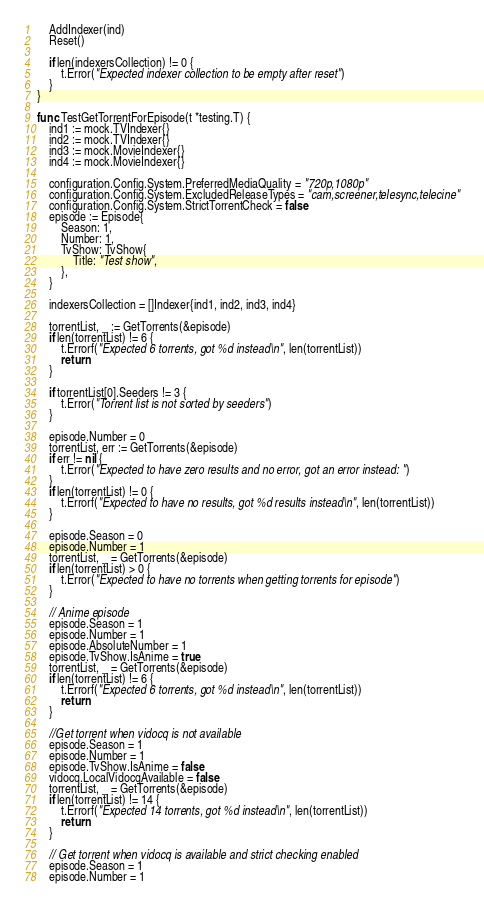<code> <loc_0><loc_0><loc_500><loc_500><_Go_>	AddIndexer(ind)
	Reset()

	if len(indexersCollection) != 0 {
		t.Error("Expected indexer collection to be empty after reset")
	}
}

func TestGetTorrentForEpisode(t *testing.T) {
	ind1 := mock.TVIndexer{}
	ind2 := mock.TVIndexer{}
	ind3 := mock.MovieIndexer{}
	ind4 := mock.MovieIndexer{}

	configuration.Config.System.PreferredMediaQuality = "720p,1080p"
	configuration.Config.System.ExcludedReleaseTypes = "cam,screener,telesync,telecine"
	configuration.Config.System.StrictTorrentCheck = false
	episode := Episode{
		Season: 1,
		Number: 1,
		TvShow: TvShow{
			Title: "Test show",
		},
	}

	indexersCollection = []Indexer{ind1, ind2, ind3, ind4}

	torrentList, _ := GetTorrents(&episode)
	if len(torrentList) != 6 {
		t.Errorf("Expected 6 torrents, got %d instead\n", len(torrentList))
		return
	}

	if torrentList[0].Seeders != 3 {
		t.Error("Torrent list is not sorted by seeders")
	}

	episode.Number = 0
	torrentList, err := GetTorrents(&episode)
	if err != nil {
		t.Error("Expected to have zero results and no error, got an error instead: ")
	}
	if len(torrentList) != 0 {
		t.Errorf("Expected to have no results, got %d results instead\n", len(torrentList))
	}

	episode.Season = 0
	episode.Number = 1
	torrentList, _ = GetTorrents(&episode)
	if len(torrentList) > 0 {
		t.Error("Expected to have no torrents when getting torrents for episode")
	}

	// Anime episode
	episode.Season = 1
	episode.Number = 1
	episode.AbsoluteNumber = 1
	episode.TvShow.IsAnime = true
	torrentList, _ = GetTorrents(&episode)
	if len(torrentList) != 6 {
		t.Errorf("Expected 6 torrents, got %d instead\n", len(torrentList))
		return
	}

	//Get torrent when vidocq is not available
	episode.Season = 1
	episode.Number = 1
	episode.TvShow.IsAnime = false
	vidocq.LocalVidocqAvailable = false
	torrentList, _ = GetTorrents(&episode)
	if len(torrentList) != 14 {
		t.Errorf("Expected 14 torrents, got %d instead\n", len(torrentList))
		return
	}

	// Get torrent when vidocq is available and strict checking enabled
	episode.Season = 1
	episode.Number = 1</code> 